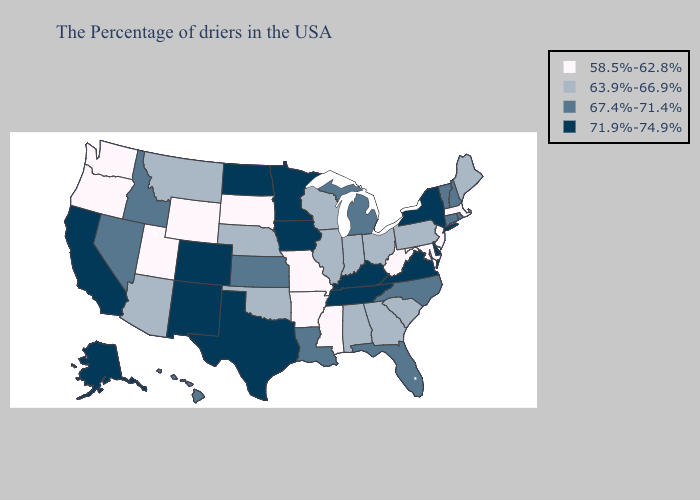What is the value of Louisiana?
Short answer required. 67.4%-71.4%. Does Idaho have the lowest value in the USA?
Give a very brief answer. No. Name the states that have a value in the range 71.9%-74.9%?
Write a very short answer. New York, Delaware, Virginia, Kentucky, Tennessee, Minnesota, Iowa, Texas, North Dakota, Colorado, New Mexico, California, Alaska. Which states have the lowest value in the USA?
Concise answer only. Massachusetts, New Jersey, Maryland, West Virginia, Mississippi, Missouri, Arkansas, South Dakota, Wyoming, Utah, Washington, Oregon. Does Utah have the lowest value in the West?
Concise answer only. Yes. Does Alabama have the same value as Oklahoma?
Keep it brief. Yes. Which states hav the highest value in the Northeast?
Keep it brief. New York. Name the states that have a value in the range 58.5%-62.8%?
Be succinct. Massachusetts, New Jersey, Maryland, West Virginia, Mississippi, Missouri, Arkansas, South Dakota, Wyoming, Utah, Washington, Oregon. Does Tennessee have the highest value in the South?
Be succinct. Yes. Name the states that have a value in the range 71.9%-74.9%?
Short answer required. New York, Delaware, Virginia, Kentucky, Tennessee, Minnesota, Iowa, Texas, North Dakota, Colorado, New Mexico, California, Alaska. What is the value of Massachusetts?
Concise answer only. 58.5%-62.8%. What is the lowest value in the USA?
Be succinct. 58.5%-62.8%. Among the states that border Mississippi , does Arkansas have the lowest value?
Short answer required. Yes. Does the map have missing data?
Write a very short answer. No. 